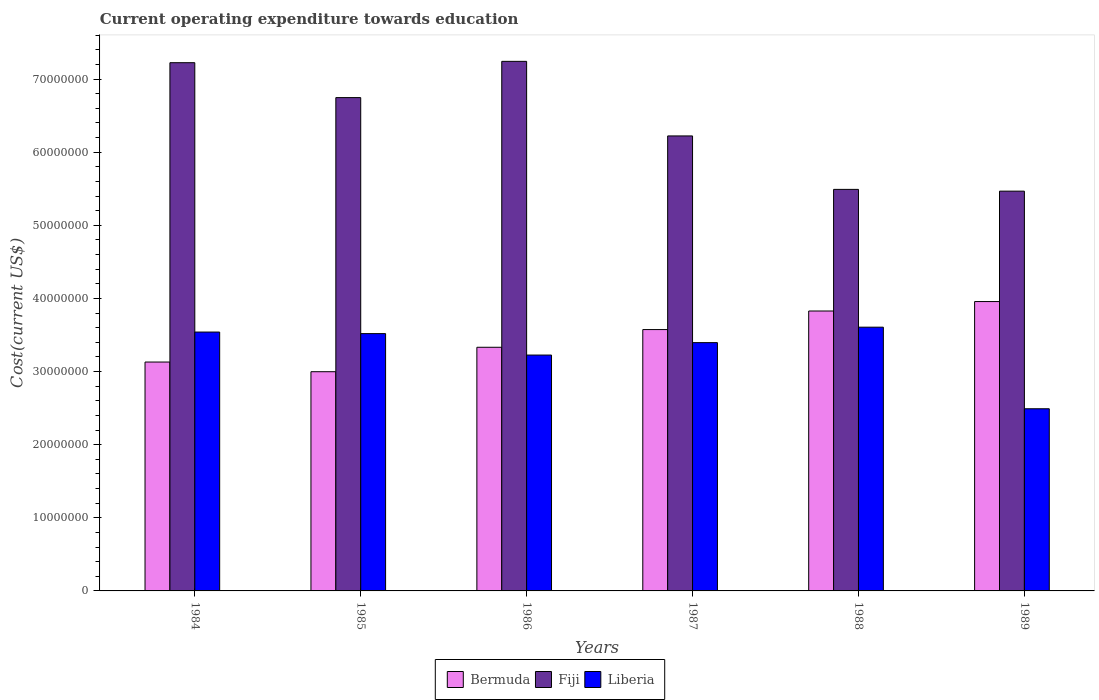Are the number of bars per tick equal to the number of legend labels?
Make the answer very short. Yes. How many bars are there on the 1st tick from the left?
Offer a terse response. 3. What is the label of the 4th group of bars from the left?
Your response must be concise. 1987. In how many cases, is the number of bars for a given year not equal to the number of legend labels?
Make the answer very short. 0. What is the expenditure towards education in Fiji in 1989?
Make the answer very short. 5.47e+07. Across all years, what is the maximum expenditure towards education in Bermuda?
Your response must be concise. 3.96e+07. Across all years, what is the minimum expenditure towards education in Bermuda?
Ensure brevity in your answer.  3.00e+07. What is the total expenditure towards education in Liberia in the graph?
Your response must be concise. 1.98e+08. What is the difference between the expenditure towards education in Bermuda in 1984 and that in 1987?
Make the answer very short. -4.44e+06. What is the difference between the expenditure towards education in Liberia in 1988 and the expenditure towards education in Bermuda in 1987?
Make the answer very short. 3.27e+05. What is the average expenditure towards education in Bermuda per year?
Offer a terse response. 3.47e+07. In the year 1985, what is the difference between the expenditure towards education in Bermuda and expenditure towards education in Fiji?
Give a very brief answer. -3.75e+07. In how many years, is the expenditure towards education in Fiji greater than 24000000 US$?
Your response must be concise. 6. What is the ratio of the expenditure towards education in Liberia in 1987 to that in 1989?
Provide a succinct answer. 1.36. Is the expenditure towards education in Fiji in 1984 less than that in 1987?
Give a very brief answer. No. Is the difference between the expenditure towards education in Bermuda in 1988 and 1989 greater than the difference between the expenditure towards education in Fiji in 1988 and 1989?
Your answer should be compact. No. What is the difference between the highest and the second highest expenditure towards education in Fiji?
Provide a short and direct response. 1.83e+05. What is the difference between the highest and the lowest expenditure towards education in Bermuda?
Offer a very short reply. 9.59e+06. Is the sum of the expenditure towards education in Fiji in 1984 and 1987 greater than the maximum expenditure towards education in Liberia across all years?
Offer a terse response. Yes. What does the 2nd bar from the left in 1989 represents?
Keep it short and to the point. Fiji. What does the 3rd bar from the right in 1986 represents?
Keep it short and to the point. Bermuda. Is it the case that in every year, the sum of the expenditure towards education in Bermuda and expenditure towards education in Liberia is greater than the expenditure towards education in Fiji?
Keep it short and to the point. No. Are all the bars in the graph horizontal?
Ensure brevity in your answer.  No. Does the graph contain any zero values?
Give a very brief answer. No. Does the graph contain grids?
Your response must be concise. No. Where does the legend appear in the graph?
Give a very brief answer. Bottom center. How are the legend labels stacked?
Your answer should be very brief. Horizontal. What is the title of the graph?
Give a very brief answer. Current operating expenditure towards education. What is the label or title of the X-axis?
Your answer should be very brief. Years. What is the label or title of the Y-axis?
Give a very brief answer. Cost(current US$). What is the Cost(current US$) of Bermuda in 1984?
Keep it short and to the point. 3.13e+07. What is the Cost(current US$) of Fiji in 1984?
Make the answer very short. 7.22e+07. What is the Cost(current US$) in Liberia in 1984?
Your answer should be compact. 3.54e+07. What is the Cost(current US$) of Bermuda in 1985?
Provide a short and direct response. 3.00e+07. What is the Cost(current US$) of Fiji in 1985?
Provide a succinct answer. 6.75e+07. What is the Cost(current US$) in Liberia in 1985?
Offer a terse response. 3.52e+07. What is the Cost(current US$) in Bermuda in 1986?
Keep it short and to the point. 3.33e+07. What is the Cost(current US$) in Fiji in 1986?
Give a very brief answer. 7.24e+07. What is the Cost(current US$) in Liberia in 1986?
Ensure brevity in your answer.  3.23e+07. What is the Cost(current US$) of Bermuda in 1987?
Your response must be concise. 3.57e+07. What is the Cost(current US$) of Fiji in 1987?
Keep it short and to the point. 6.22e+07. What is the Cost(current US$) in Liberia in 1987?
Provide a succinct answer. 3.40e+07. What is the Cost(current US$) of Bermuda in 1988?
Make the answer very short. 3.83e+07. What is the Cost(current US$) in Fiji in 1988?
Ensure brevity in your answer.  5.49e+07. What is the Cost(current US$) in Liberia in 1988?
Offer a very short reply. 3.61e+07. What is the Cost(current US$) of Bermuda in 1989?
Provide a succinct answer. 3.96e+07. What is the Cost(current US$) of Fiji in 1989?
Provide a short and direct response. 5.47e+07. What is the Cost(current US$) of Liberia in 1989?
Provide a short and direct response. 2.49e+07. Across all years, what is the maximum Cost(current US$) in Bermuda?
Your response must be concise. 3.96e+07. Across all years, what is the maximum Cost(current US$) of Fiji?
Ensure brevity in your answer.  7.24e+07. Across all years, what is the maximum Cost(current US$) in Liberia?
Your answer should be very brief. 3.61e+07. Across all years, what is the minimum Cost(current US$) of Bermuda?
Provide a short and direct response. 3.00e+07. Across all years, what is the minimum Cost(current US$) in Fiji?
Give a very brief answer. 5.47e+07. Across all years, what is the minimum Cost(current US$) in Liberia?
Your answer should be compact. 2.49e+07. What is the total Cost(current US$) in Bermuda in the graph?
Offer a terse response. 2.08e+08. What is the total Cost(current US$) of Fiji in the graph?
Your answer should be compact. 3.84e+08. What is the total Cost(current US$) in Liberia in the graph?
Provide a short and direct response. 1.98e+08. What is the difference between the Cost(current US$) in Bermuda in 1984 and that in 1985?
Give a very brief answer. 1.32e+06. What is the difference between the Cost(current US$) of Fiji in 1984 and that in 1985?
Provide a succinct answer. 4.78e+06. What is the difference between the Cost(current US$) in Liberia in 1984 and that in 1985?
Ensure brevity in your answer.  2.14e+05. What is the difference between the Cost(current US$) of Bermuda in 1984 and that in 1986?
Provide a succinct answer. -2.02e+06. What is the difference between the Cost(current US$) of Fiji in 1984 and that in 1986?
Offer a terse response. -1.83e+05. What is the difference between the Cost(current US$) in Liberia in 1984 and that in 1986?
Your response must be concise. 3.15e+06. What is the difference between the Cost(current US$) of Bermuda in 1984 and that in 1987?
Your response must be concise. -4.44e+06. What is the difference between the Cost(current US$) in Fiji in 1984 and that in 1987?
Keep it short and to the point. 1.00e+07. What is the difference between the Cost(current US$) in Liberia in 1984 and that in 1987?
Your response must be concise. 1.45e+06. What is the difference between the Cost(current US$) of Bermuda in 1984 and that in 1988?
Keep it short and to the point. -6.98e+06. What is the difference between the Cost(current US$) of Fiji in 1984 and that in 1988?
Offer a terse response. 1.73e+07. What is the difference between the Cost(current US$) of Liberia in 1984 and that in 1988?
Ensure brevity in your answer.  -6.67e+05. What is the difference between the Cost(current US$) in Bermuda in 1984 and that in 1989?
Offer a very short reply. -8.27e+06. What is the difference between the Cost(current US$) in Fiji in 1984 and that in 1989?
Ensure brevity in your answer.  1.76e+07. What is the difference between the Cost(current US$) in Liberia in 1984 and that in 1989?
Provide a short and direct response. 1.05e+07. What is the difference between the Cost(current US$) of Bermuda in 1985 and that in 1986?
Provide a short and direct response. -3.34e+06. What is the difference between the Cost(current US$) in Fiji in 1985 and that in 1986?
Make the answer very short. -4.96e+06. What is the difference between the Cost(current US$) in Liberia in 1985 and that in 1986?
Give a very brief answer. 2.93e+06. What is the difference between the Cost(current US$) of Bermuda in 1985 and that in 1987?
Keep it short and to the point. -5.76e+06. What is the difference between the Cost(current US$) in Fiji in 1985 and that in 1987?
Offer a terse response. 5.24e+06. What is the difference between the Cost(current US$) of Liberia in 1985 and that in 1987?
Your answer should be compact. 1.23e+06. What is the difference between the Cost(current US$) of Bermuda in 1985 and that in 1988?
Provide a short and direct response. -8.30e+06. What is the difference between the Cost(current US$) of Fiji in 1985 and that in 1988?
Provide a short and direct response. 1.26e+07. What is the difference between the Cost(current US$) of Liberia in 1985 and that in 1988?
Keep it short and to the point. -8.81e+05. What is the difference between the Cost(current US$) of Bermuda in 1985 and that in 1989?
Your answer should be very brief. -9.59e+06. What is the difference between the Cost(current US$) in Fiji in 1985 and that in 1989?
Your answer should be very brief. 1.28e+07. What is the difference between the Cost(current US$) of Liberia in 1985 and that in 1989?
Make the answer very short. 1.03e+07. What is the difference between the Cost(current US$) in Bermuda in 1986 and that in 1987?
Make the answer very short. -2.42e+06. What is the difference between the Cost(current US$) of Fiji in 1986 and that in 1987?
Your response must be concise. 1.02e+07. What is the difference between the Cost(current US$) in Liberia in 1986 and that in 1987?
Provide a succinct answer. -1.70e+06. What is the difference between the Cost(current US$) of Bermuda in 1986 and that in 1988?
Your answer should be compact. -4.96e+06. What is the difference between the Cost(current US$) in Fiji in 1986 and that in 1988?
Provide a short and direct response. 1.75e+07. What is the difference between the Cost(current US$) in Liberia in 1986 and that in 1988?
Your answer should be very brief. -3.81e+06. What is the difference between the Cost(current US$) in Bermuda in 1986 and that in 1989?
Provide a short and direct response. -6.25e+06. What is the difference between the Cost(current US$) of Fiji in 1986 and that in 1989?
Your answer should be compact. 1.78e+07. What is the difference between the Cost(current US$) in Liberia in 1986 and that in 1989?
Offer a very short reply. 7.34e+06. What is the difference between the Cost(current US$) of Bermuda in 1987 and that in 1988?
Your response must be concise. -2.54e+06. What is the difference between the Cost(current US$) in Fiji in 1987 and that in 1988?
Your answer should be very brief. 7.31e+06. What is the difference between the Cost(current US$) of Liberia in 1987 and that in 1988?
Make the answer very short. -2.12e+06. What is the difference between the Cost(current US$) of Bermuda in 1987 and that in 1989?
Offer a very short reply. -3.83e+06. What is the difference between the Cost(current US$) of Fiji in 1987 and that in 1989?
Ensure brevity in your answer.  7.55e+06. What is the difference between the Cost(current US$) of Liberia in 1987 and that in 1989?
Your answer should be compact. 9.04e+06. What is the difference between the Cost(current US$) of Bermuda in 1988 and that in 1989?
Give a very brief answer. -1.29e+06. What is the difference between the Cost(current US$) of Fiji in 1988 and that in 1989?
Offer a very short reply. 2.42e+05. What is the difference between the Cost(current US$) of Liberia in 1988 and that in 1989?
Your answer should be very brief. 1.12e+07. What is the difference between the Cost(current US$) in Bermuda in 1984 and the Cost(current US$) in Fiji in 1985?
Give a very brief answer. -3.62e+07. What is the difference between the Cost(current US$) of Bermuda in 1984 and the Cost(current US$) of Liberia in 1985?
Keep it short and to the point. -3.89e+06. What is the difference between the Cost(current US$) of Fiji in 1984 and the Cost(current US$) of Liberia in 1985?
Keep it short and to the point. 3.71e+07. What is the difference between the Cost(current US$) in Bermuda in 1984 and the Cost(current US$) in Fiji in 1986?
Keep it short and to the point. -4.11e+07. What is the difference between the Cost(current US$) of Bermuda in 1984 and the Cost(current US$) of Liberia in 1986?
Give a very brief answer. -9.54e+05. What is the difference between the Cost(current US$) of Fiji in 1984 and the Cost(current US$) of Liberia in 1986?
Ensure brevity in your answer.  4.00e+07. What is the difference between the Cost(current US$) in Bermuda in 1984 and the Cost(current US$) in Fiji in 1987?
Your response must be concise. -3.09e+07. What is the difference between the Cost(current US$) in Bermuda in 1984 and the Cost(current US$) in Liberia in 1987?
Offer a terse response. -2.65e+06. What is the difference between the Cost(current US$) in Fiji in 1984 and the Cost(current US$) in Liberia in 1987?
Offer a terse response. 3.83e+07. What is the difference between the Cost(current US$) of Bermuda in 1984 and the Cost(current US$) of Fiji in 1988?
Your response must be concise. -2.36e+07. What is the difference between the Cost(current US$) in Bermuda in 1984 and the Cost(current US$) in Liberia in 1988?
Offer a terse response. -4.77e+06. What is the difference between the Cost(current US$) of Fiji in 1984 and the Cost(current US$) of Liberia in 1988?
Ensure brevity in your answer.  3.62e+07. What is the difference between the Cost(current US$) of Bermuda in 1984 and the Cost(current US$) of Fiji in 1989?
Your answer should be very brief. -2.34e+07. What is the difference between the Cost(current US$) of Bermuda in 1984 and the Cost(current US$) of Liberia in 1989?
Make the answer very short. 6.39e+06. What is the difference between the Cost(current US$) of Fiji in 1984 and the Cost(current US$) of Liberia in 1989?
Your answer should be very brief. 4.73e+07. What is the difference between the Cost(current US$) of Bermuda in 1985 and the Cost(current US$) of Fiji in 1986?
Your response must be concise. -4.24e+07. What is the difference between the Cost(current US$) of Bermuda in 1985 and the Cost(current US$) of Liberia in 1986?
Give a very brief answer. -2.28e+06. What is the difference between the Cost(current US$) of Fiji in 1985 and the Cost(current US$) of Liberia in 1986?
Ensure brevity in your answer.  3.52e+07. What is the difference between the Cost(current US$) in Bermuda in 1985 and the Cost(current US$) in Fiji in 1987?
Your answer should be very brief. -3.22e+07. What is the difference between the Cost(current US$) in Bermuda in 1985 and the Cost(current US$) in Liberia in 1987?
Provide a succinct answer. -3.98e+06. What is the difference between the Cost(current US$) of Fiji in 1985 and the Cost(current US$) of Liberia in 1987?
Provide a short and direct response. 3.35e+07. What is the difference between the Cost(current US$) of Bermuda in 1985 and the Cost(current US$) of Fiji in 1988?
Your answer should be very brief. -2.49e+07. What is the difference between the Cost(current US$) of Bermuda in 1985 and the Cost(current US$) of Liberia in 1988?
Your answer should be compact. -6.09e+06. What is the difference between the Cost(current US$) of Fiji in 1985 and the Cost(current US$) of Liberia in 1988?
Offer a terse response. 3.14e+07. What is the difference between the Cost(current US$) in Bermuda in 1985 and the Cost(current US$) in Fiji in 1989?
Your answer should be very brief. -2.47e+07. What is the difference between the Cost(current US$) in Bermuda in 1985 and the Cost(current US$) in Liberia in 1989?
Provide a short and direct response. 5.07e+06. What is the difference between the Cost(current US$) of Fiji in 1985 and the Cost(current US$) of Liberia in 1989?
Your answer should be compact. 4.26e+07. What is the difference between the Cost(current US$) in Bermuda in 1986 and the Cost(current US$) in Fiji in 1987?
Your answer should be compact. -2.89e+07. What is the difference between the Cost(current US$) in Bermuda in 1986 and the Cost(current US$) in Liberia in 1987?
Make the answer very short. -6.34e+05. What is the difference between the Cost(current US$) of Fiji in 1986 and the Cost(current US$) of Liberia in 1987?
Offer a very short reply. 3.85e+07. What is the difference between the Cost(current US$) in Bermuda in 1986 and the Cost(current US$) in Fiji in 1988?
Offer a very short reply. -2.16e+07. What is the difference between the Cost(current US$) of Bermuda in 1986 and the Cost(current US$) of Liberia in 1988?
Offer a terse response. -2.75e+06. What is the difference between the Cost(current US$) of Fiji in 1986 and the Cost(current US$) of Liberia in 1988?
Provide a short and direct response. 3.64e+07. What is the difference between the Cost(current US$) in Bermuda in 1986 and the Cost(current US$) in Fiji in 1989?
Your answer should be compact. -2.14e+07. What is the difference between the Cost(current US$) of Bermuda in 1986 and the Cost(current US$) of Liberia in 1989?
Provide a short and direct response. 8.41e+06. What is the difference between the Cost(current US$) of Fiji in 1986 and the Cost(current US$) of Liberia in 1989?
Provide a short and direct response. 4.75e+07. What is the difference between the Cost(current US$) in Bermuda in 1987 and the Cost(current US$) in Fiji in 1988?
Your answer should be very brief. -1.92e+07. What is the difference between the Cost(current US$) in Bermuda in 1987 and the Cost(current US$) in Liberia in 1988?
Give a very brief answer. -3.27e+05. What is the difference between the Cost(current US$) in Fiji in 1987 and the Cost(current US$) in Liberia in 1988?
Provide a short and direct response. 2.62e+07. What is the difference between the Cost(current US$) in Bermuda in 1987 and the Cost(current US$) in Fiji in 1989?
Your answer should be very brief. -1.89e+07. What is the difference between the Cost(current US$) of Bermuda in 1987 and the Cost(current US$) of Liberia in 1989?
Make the answer very short. 1.08e+07. What is the difference between the Cost(current US$) in Fiji in 1987 and the Cost(current US$) in Liberia in 1989?
Offer a very short reply. 3.73e+07. What is the difference between the Cost(current US$) in Bermuda in 1988 and the Cost(current US$) in Fiji in 1989?
Your answer should be very brief. -1.64e+07. What is the difference between the Cost(current US$) of Bermuda in 1988 and the Cost(current US$) of Liberia in 1989?
Your answer should be compact. 1.34e+07. What is the difference between the Cost(current US$) in Fiji in 1988 and the Cost(current US$) in Liberia in 1989?
Your response must be concise. 3.00e+07. What is the average Cost(current US$) in Bermuda per year?
Give a very brief answer. 3.47e+07. What is the average Cost(current US$) of Fiji per year?
Your answer should be very brief. 6.40e+07. What is the average Cost(current US$) in Liberia per year?
Your answer should be compact. 3.30e+07. In the year 1984, what is the difference between the Cost(current US$) of Bermuda and Cost(current US$) of Fiji?
Provide a short and direct response. -4.09e+07. In the year 1984, what is the difference between the Cost(current US$) in Bermuda and Cost(current US$) in Liberia?
Give a very brief answer. -4.10e+06. In the year 1984, what is the difference between the Cost(current US$) of Fiji and Cost(current US$) of Liberia?
Keep it short and to the point. 3.68e+07. In the year 1985, what is the difference between the Cost(current US$) in Bermuda and Cost(current US$) in Fiji?
Your response must be concise. -3.75e+07. In the year 1985, what is the difference between the Cost(current US$) in Bermuda and Cost(current US$) in Liberia?
Offer a very short reply. -5.21e+06. In the year 1985, what is the difference between the Cost(current US$) in Fiji and Cost(current US$) in Liberia?
Make the answer very short. 3.23e+07. In the year 1986, what is the difference between the Cost(current US$) in Bermuda and Cost(current US$) in Fiji?
Give a very brief answer. -3.91e+07. In the year 1986, what is the difference between the Cost(current US$) of Bermuda and Cost(current US$) of Liberia?
Provide a short and direct response. 1.07e+06. In the year 1986, what is the difference between the Cost(current US$) of Fiji and Cost(current US$) of Liberia?
Your answer should be very brief. 4.02e+07. In the year 1987, what is the difference between the Cost(current US$) of Bermuda and Cost(current US$) of Fiji?
Make the answer very short. -2.65e+07. In the year 1987, what is the difference between the Cost(current US$) in Bermuda and Cost(current US$) in Liberia?
Offer a very short reply. 1.79e+06. In the year 1987, what is the difference between the Cost(current US$) in Fiji and Cost(current US$) in Liberia?
Your response must be concise. 2.83e+07. In the year 1988, what is the difference between the Cost(current US$) in Bermuda and Cost(current US$) in Fiji?
Provide a succinct answer. -1.66e+07. In the year 1988, what is the difference between the Cost(current US$) of Bermuda and Cost(current US$) of Liberia?
Keep it short and to the point. 2.21e+06. In the year 1988, what is the difference between the Cost(current US$) of Fiji and Cost(current US$) of Liberia?
Provide a short and direct response. 1.88e+07. In the year 1989, what is the difference between the Cost(current US$) of Bermuda and Cost(current US$) of Fiji?
Provide a short and direct response. -1.51e+07. In the year 1989, what is the difference between the Cost(current US$) of Bermuda and Cost(current US$) of Liberia?
Your answer should be compact. 1.47e+07. In the year 1989, what is the difference between the Cost(current US$) in Fiji and Cost(current US$) in Liberia?
Make the answer very short. 2.98e+07. What is the ratio of the Cost(current US$) in Bermuda in 1984 to that in 1985?
Give a very brief answer. 1.04. What is the ratio of the Cost(current US$) in Fiji in 1984 to that in 1985?
Give a very brief answer. 1.07. What is the ratio of the Cost(current US$) in Bermuda in 1984 to that in 1986?
Your answer should be compact. 0.94. What is the ratio of the Cost(current US$) of Liberia in 1984 to that in 1986?
Your answer should be compact. 1.1. What is the ratio of the Cost(current US$) of Bermuda in 1984 to that in 1987?
Offer a terse response. 0.88. What is the ratio of the Cost(current US$) in Fiji in 1984 to that in 1987?
Keep it short and to the point. 1.16. What is the ratio of the Cost(current US$) in Liberia in 1984 to that in 1987?
Offer a very short reply. 1.04. What is the ratio of the Cost(current US$) of Bermuda in 1984 to that in 1988?
Your response must be concise. 0.82. What is the ratio of the Cost(current US$) of Fiji in 1984 to that in 1988?
Your answer should be very brief. 1.32. What is the ratio of the Cost(current US$) of Liberia in 1984 to that in 1988?
Give a very brief answer. 0.98. What is the ratio of the Cost(current US$) of Bermuda in 1984 to that in 1989?
Keep it short and to the point. 0.79. What is the ratio of the Cost(current US$) in Fiji in 1984 to that in 1989?
Keep it short and to the point. 1.32. What is the ratio of the Cost(current US$) of Liberia in 1984 to that in 1989?
Your answer should be compact. 1.42. What is the ratio of the Cost(current US$) in Bermuda in 1985 to that in 1986?
Your response must be concise. 0.9. What is the ratio of the Cost(current US$) in Fiji in 1985 to that in 1986?
Keep it short and to the point. 0.93. What is the ratio of the Cost(current US$) of Liberia in 1985 to that in 1986?
Make the answer very short. 1.09. What is the ratio of the Cost(current US$) in Bermuda in 1985 to that in 1987?
Provide a short and direct response. 0.84. What is the ratio of the Cost(current US$) in Fiji in 1985 to that in 1987?
Provide a short and direct response. 1.08. What is the ratio of the Cost(current US$) in Liberia in 1985 to that in 1987?
Your response must be concise. 1.04. What is the ratio of the Cost(current US$) in Bermuda in 1985 to that in 1988?
Your answer should be compact. 0.78. What is the ratio of the Cost(current US$) in Fiji in 1985 to that in 1988?
Your answer should be compact. 1.23. What is the ratio of the Cost(current US$) in Liberia in 1985 to that in 1988?
Your answer should be compact. 0.98. What is the ratio of the Cost(current US$) of Bermuda in 1985 to that in 1989?
Offer a terse response. 0.76. What is the ratio of the Cost(current US$) in Fiji in 1985 to that in 1989?
Your response must be concise. 1.23. What is the ratio of the Cost(current US$) of Liberia in 1985 to that in 1989?
Your answer should be compact. 1.41. What is the ratio of the Cost(current US$) of Bermuda in 1986 to that in 1987?
Provide a succinct answer. 0.93. What is the ratio of the Cost(current US$) in Fiji in 1986 to that in 1987?
Your response must be concise. 1.16. What is the ratio of the Cost(current US$) of Liberia in 1986 to that in 1987?
Your response must be concise. 0.95. What is the ratio of the Cost(current US$) of Bermuda in 1986 to that in 1988?
Give a very brief answer. 0.87. What is the ratio of the Cost(current US$) in Fiji in 1986 to that in 1988?
Provide a succinct answer. 1.32. What is the ratio of the Cost(current US$) of Liberia in 1986 to that in 1988?
Offer a very short reply. 0.89. What is the ratio of the Cost(current US$) of Bermuda in 1986 to that in 1989?
Make the answer very short. 0.84. What is the ratio of the Cost(current US$) in Fiji in 1986 to that in 1989?
Your response must be concise. 1.32. What is the ratio of the Cost(current US$) in Liberia in 1986 to that in 1989?
Give a very brief answer. 1.29. What is the ratio of the Cost(current US$) in Bermuda in 1987 to that in 1988?
Your answer should be very brief. 0.93. What is the ratio of the Cost(current US$) of Fiji in 1987 to that in 1988?
Provide a succinct answer. 1.13. What is the ratio of the Cost(current US$) of Liberia in 1987 to that in 1988?
Give a very brief answer. 0.94. What is the ratio of the Cost(current US$) in Bermuda in 1987 to that in 1989?
Offer a terse response. 0.9. What is the ratio of the Cost(current US$) of Fiji in 1987 to that in 1989?
Ensure brevity in your answer.  1.14. What is the ratio of the Cost(current US$) in Liberia in 1987 to that in 1989?
Your response must be concise. 1.36. What is the ratio of the Cost(current US$) in Bermuda in 1988 to that in 1989?
Provide a short and direct response. 0.97. What is the ratio of the Cost(current US$) in Fiji in 1988 to that in 1989?
Your answer should be compact. 1. What is the ratio of the Cost(current US$) of Liberia in 1988 to that in 1989?
Your answer should be very brief. 1.45. What is the difference between the highest and the second highest Cost(current US$) of Bermuda?
Keep it short and to the point. 1.29e+06. What is the difference between the highest and the second highest Cost(current US$) in Fiji?
Give a very brief answer. 1.83e+05. What is the difference between the highest and the second highest Cost(current US$) of Liberia?
Keep it short and to the point. 6.67e+05. What is the difference between the highest and the lowest Cost(current US$) in Bermuda?
Your answer should be very brief. 9.59e+06. What is the difference between the highest and the lowest Cost(current US$) in Fiji?
Give a very brief answer. 1.78e+07. What is the difference between the highest and the lowest Cost(current US$) of Liberia?
Keep it short and to the point. 1.12e+07. 